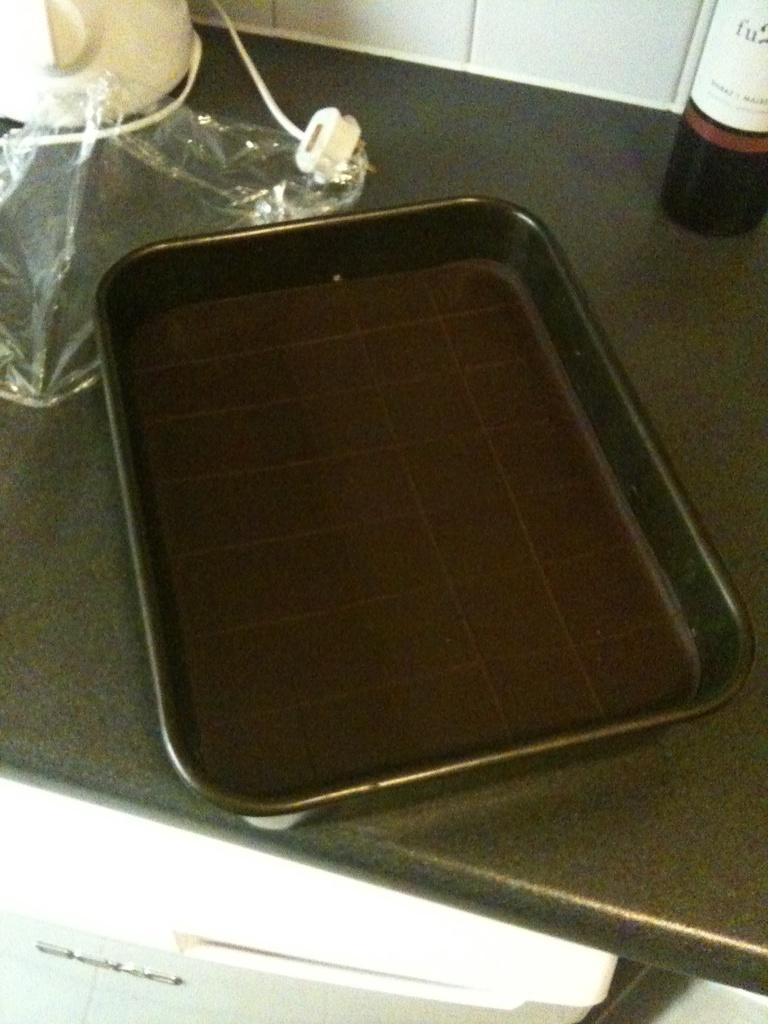What can be seen in the foreground of the image? There is a kitchen platform with objects on it in the foreground of the image. What is visible in the background of the image? There is a wall in the background of the image. Can you describe the object at the bottom of the image? Unfortunately, the facts provided do not give any information about the object at the bottom of the image. How does the zephyr affect the hill in the image? There is no zephyr or hill present in the image. What type of sleet can be seen falling from the sky in the image? There is no sleet present in the image. 